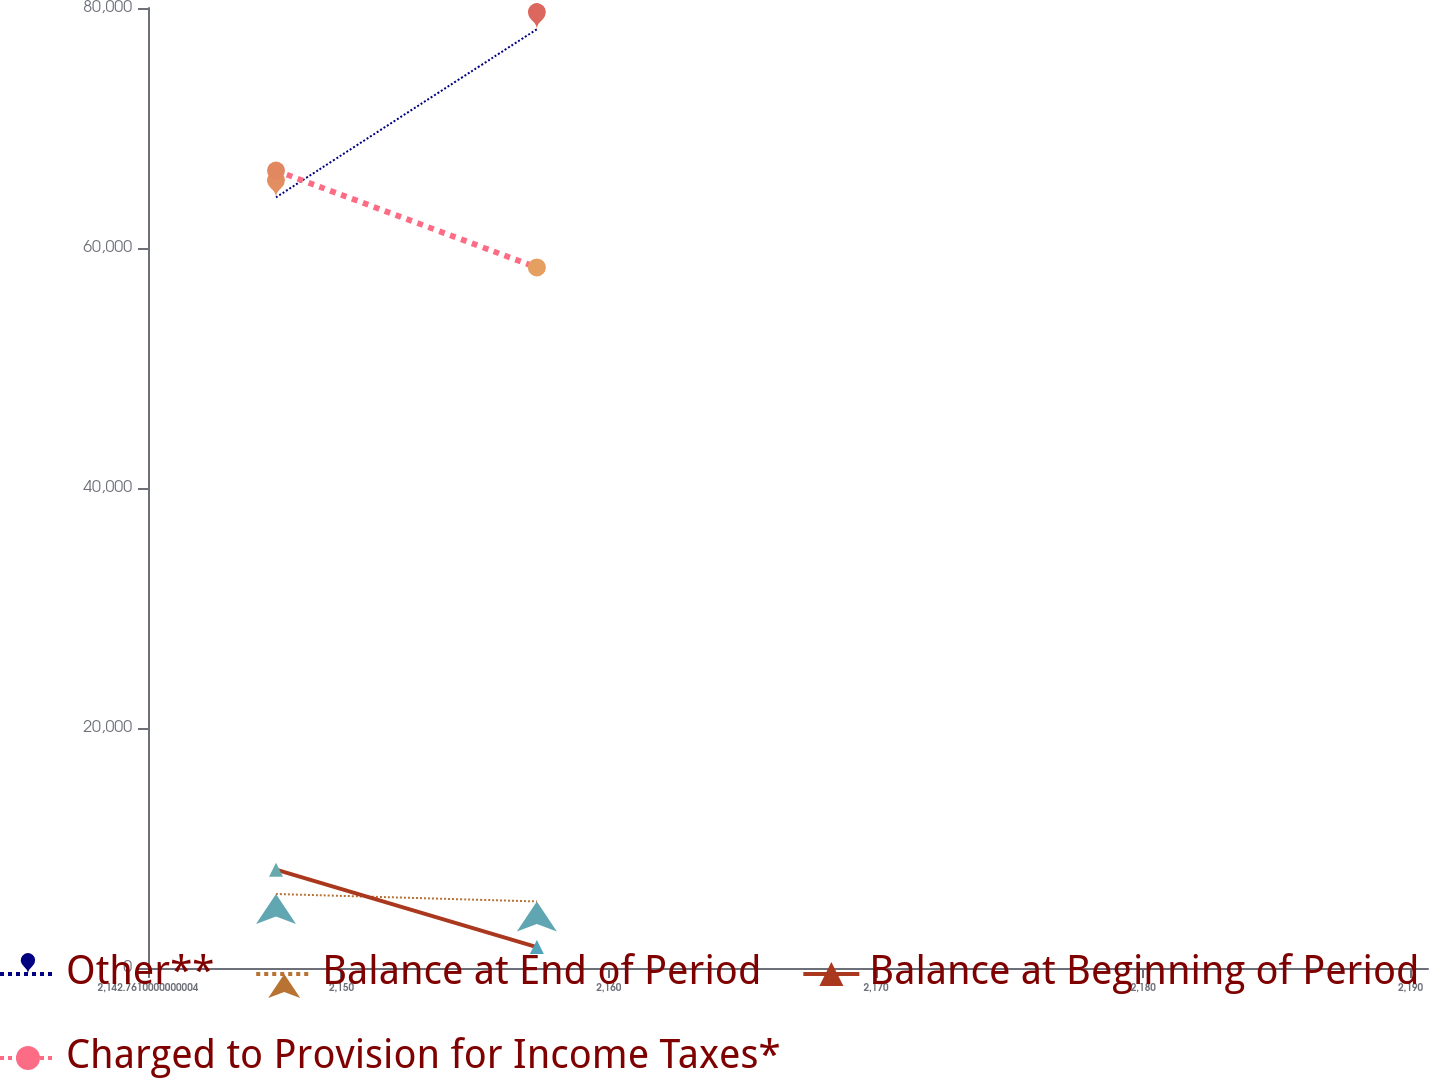<chart> <loc_0><loc_0><loc_500><loc_500><line_chart><ecel><fcel>Other**<fcel>Balance at End of Period<fcel>Balance at Beginning of Period<fcel>Charged to Provision for Income Taxes*<nl><fcel>2147.55<fcel>64220<fcel>6166.38<fcel>8196.67<fcel>66452.3<nl><fcel>2157.31<fcel>78229<fcel>5545.82<fcel>1745.56<fcel>58380.1<nl><fcel>2195.44<fcel>86976.1<fcel>1503.01<fcel>14040.8<fcel>73780.6<nl></chart> 